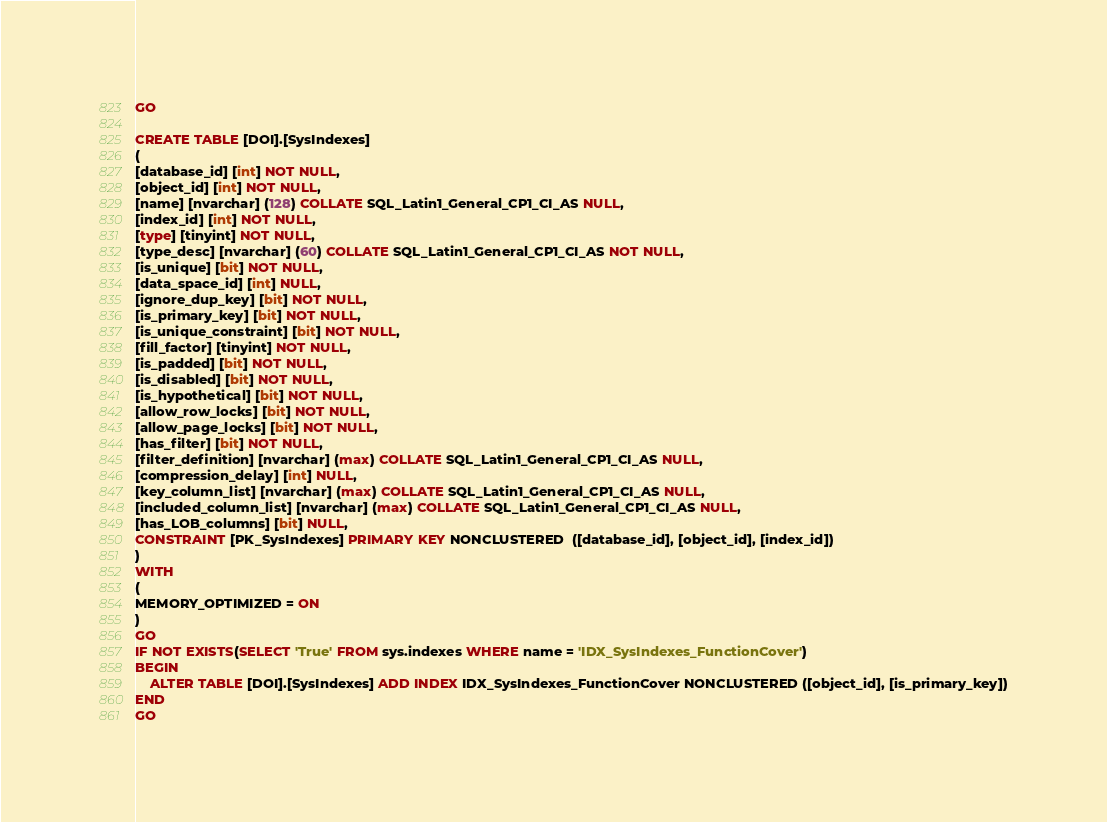Convert code to text. <code><loc_0><loc_0><loc_500><loc_500><_SQL_>
GO

CREATE TABLE [DOI].[SysIndexes]
(
[database_id] [int] NOT NULL,
[object_id] [int] NOT NULL,
[name] [nvarchar] (128) COLLATE SQL_Latin1_General_CP1_CI_AS NULL,
[index_id] [int] NOT NULL,
[type] [tinyint] NOT NULL,
[type_desc] [nvarchar] (60) COLLATE SQL_Latin1_General_CP1_CI_AS NOT NULL,
[is_unique] [bit] NOT NULL,
[data_space_id] [int] NULL,
[ignore_dup_key] [bit] NOT NULL,
[is_primary_key] [bit] NOT NULL,
[is_unique_constraint] [bit] NOT NULL,
[fill_factor] [tinyint] NOT NULL,
[is_padded] [bit] NOT NULL,
[is_disabled] [bit] NOT NULL,
[is_hypothetical] [bit] NOT NULL,
[allow_row_locks] [bit] NOT NULL,
[allow_page_locks] [bit] NOT NULL,
[has_filter] [bit] NOT NULL,
[filter_definition] [nvarchar] (max) COLLATE SQL_Latin1_General_CP1_CI_AS NULL,
[compression_delay] [int] NULL,
[key_column_list] [nvarchar] (max) COLLATE SQL_Latin1_General_CP1_CI_AS NULL,
[included_column_list] [nvarchar] (max) COLLATE SQL_Latin1_General_CP1_CI_AS NULL,
[has_LOB_columns] [bit] NULL,
CONSTRAINT [PK_SysIndexes] PRIMARY KEY NONCLUSTERED  ([database_id], [object_id], [index_id])
)
WITH
(
MEMORY_OPTIMIZED = ON
)
GO
IF NOT EXISTS(SELECT 'True' FROM sys.indexes WHERE name = 'IDX_SysIndexes_FunctionCover')
BEGIN
    ALTER TABLE [DOI].[SysIndexes] ADD INDEX IDX_SysIndexes_FunctionCover NONCLUSTERED ([object_id], [is_primary_key])
END
GO</code> 